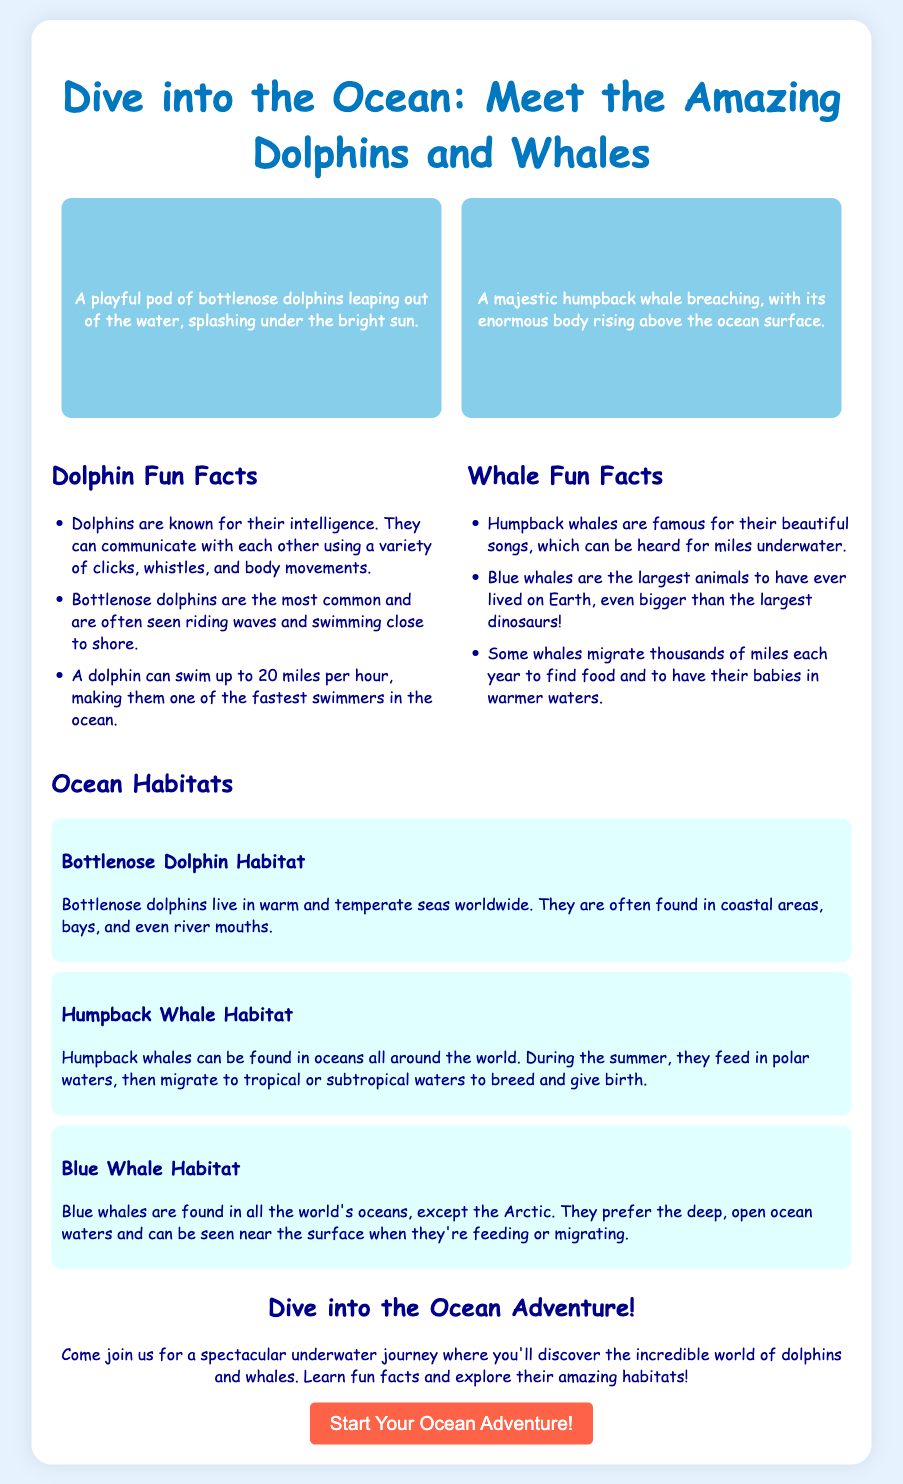What is the title of the advertisement? The title can be found at the top of the document and it is a clear heading for the content.
Answer: Dive into the Ocean: Meet the Amazing Dolphins and Whales How many dolphins are mentioned in the fun facts? The fun facts section lists facts related to dolphins, but only one type of dolphin is specifically named: bottlenose.
Answer: One What are dolphins known for? The first fun fact specifically states what dolphins are recognized for, indicating their special ability.
Answer: Intelligence What do humpback whales do to communicate? The fun fact about humpback whales indicates their method of communication, which is through their songs.
Answer: Songs Where do bottlenose dolphins typically live? The habitat description for bottlenose dolphins provides details on their typical living conditions and areas.
Answer: Warm and temperate seas What is the size rank of blue whales compared to other animals? The fun fact about blue whales directly states their size in relation to all other animals.
Answer: Largest During which season do humpback whales feed in polar waters? The information on humpback whale behavior indicates the specific time of year they engage in feeding activities.
Answer: Summer What is the call to action in the advertisement? The last section encourages participation and highlights the adventure aspect of the advertisement.
Answer: Start Your Ocean Adventure! How is the imagery of dolphins described? The description of dolphins in the imagery section details their playful nature within their environment.
Answer: Playful pod of bottlenose dolphins 